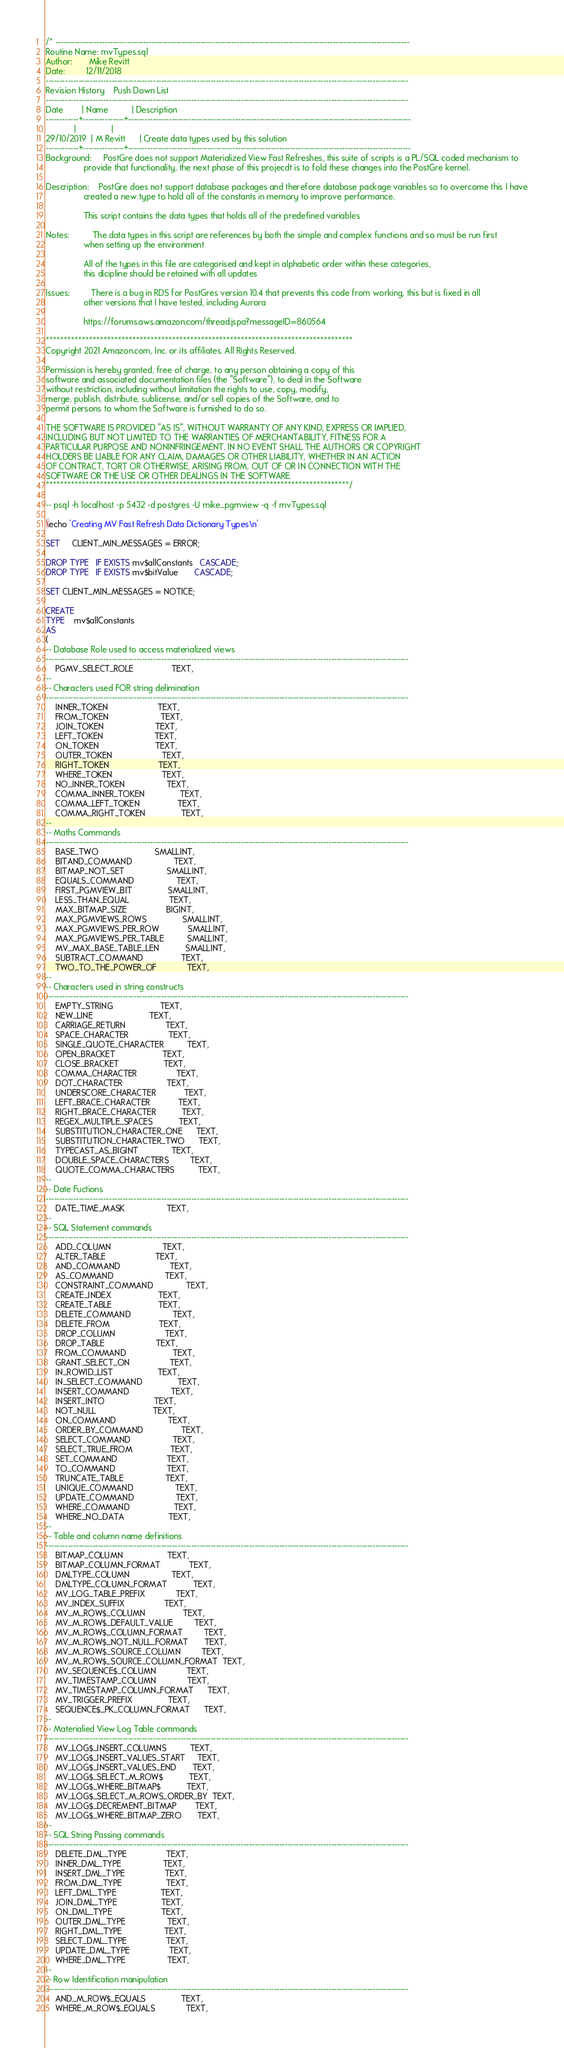<code> <loc_0><loc_0><loc_500><loc_500><_SQL_>/* ---------------------------------------------------------------------------------------------------------------------------------
Routine Name: mvTypes.sql
Author:       Mike Revitt
Date:         12/11/2018
------------------------------------------------------------------------------------------------------------------------------------
Revision History    Push Down List
------------------------------------------------------------------------------------------------------------------------------------
Date        | Name          | Description
------------+---------------+-------------------------------------------------------------------------------------------------------
            |               |
29/10/2019  | M Revitt      | Create data types used by this solution
------------+---------------+-------------------------------------------------------------------------------------------------------
Background:     PostGre does not support Materialized View Fast Refreshes, this suite of scripts is a PL/SQL coded mechanism to
                provide that functionality, the next phase of this projecdt is to fold these changes into the PostGre kernel.

Description:    PostGre does not support database packages and therefore database package variables so to overcome this I have
                created a new type to hold all of the constants in memory to improve performance.

                This script contains the data types that holds all of the predefined variables

Notes:          The data types in this script are references by both the simple and complex functions and so must be run first
                when setting up the environment

                All of the types in this file are categorised and kept in alphabetic order within these categories,
                this dicipline should be retained with all updates

Issues:         There is a bug in RDS for PostGres version 10.4 that prevents this code from working, this but is fixed in all
                other versions that I have tested, including Aurora

                https://forums.aws.amazon.com/thread.jspa?messageID=860564

*************************************************************************************
Copyright 2021 Amazon.com, Inc. or its affiliates. All Rights Reserved.

Permission is hereby granted, free of charge, to any person obtaining a copy of this
software and associated documentation files (the "Software"), to deal in the Software
without restriction, including without limitation the rights to use, copy, modify,
merge, publish, distribute, sublicense, and/or sell copies of the Software, and to
permit persons to whom the Software is furnished to do so.

THE SOFTWARE IS PROVIDED "AS IS", WITHOUT WARRANTY OF ANY KIND, EXPRESS OR IMPLIED,
INCLUDING BUT NOT LIMITED TO THE WARRANTIES OF MERCHANTABILITY, FITNESS FOR A
PARTICULAR PURPOSE AND NONINFRINGEMENT. IN NO EVENT SHALL THE AUTHORS OR COPYRIGHT
HOLDERS BE LIABLE FOR ANY CLAIM, DAMAGES OR OTHER LIABILITY, WHETHER IN AN ACTION
OF CONTRACT, TORT OR OTHERWISE, ARISING FROM, OUT OF OR IN CONNECTION WITH THE
SOFTWARE OR THE USE OR OTHER DEALINGS IN THE SOFTWARE.
************************************************************************************/

-- psql -h localhost -p 5432 -d postgres -U mike_pgmview -q -f mvTypes.sql

\echo 'Creating MV Fast Refresh Data Dictionary Types\n'

SET     CLIENT_MIN_MESSAGES = ERROR;

DROP TYPE   IF EXISTS mv$allConstants   CASCADE;
DROP TYPE   IF EXISTS mv$bitValue       CASCADE;

SET CLIENT_MIN_MESSAGES = NOTICE;

CREATE
TYPE    mv$allConstants
AS
(
-- Database Role used to access materialized views
------------------------------------------------------------------------------------------------------------------------------------
    PGMV_SELECT_ROLE                TEXT,
--
-- Characters used FOR string delimination
------------------------------------------------------------------------------------------------------------------------------------
    INNER_TOKEN                     TEXT,
    FROM_TOKEN                      TEXT,
    JOIN_TOKEN                      TEXT,
    LEFT_TOKEN                      TEXT,
    ON_TOKEN                        TEXT,
    OUTER_TOKEN                     TEXT,
    RIGHT_TOKEN                     TEXT,
    WHERE_TOKEN                     TEXT,
    NO_INNER_TOKEN                  TEXT,
    COMMA_INNER_TOKEN               TEXT,
    COMMA_LEFT_TOKEN                TEXT,
    COMMA_RIGHT_TOKEN               TEXT,
--
-- Maths Commands
------------------------------------------------------------------------------------------------------------------------------------
    BASE_TWO                        SMALLINT,
    BITAND_COMMAND                  TEXT,
    BITMAP_NOT_SET                  SMALLINT,
    EQUALS_COMMAND                  TEXT,
    FIRST_PGMVIEW_BIT               SMALLINT,
    LESS_THAN_EQUAL                 TEXT,
    MAX_BITMAP_SIZE                 BIGINT,
    MAX_PGMVIEWS_ROWS               SMALLINT,
    MAX_PGMVIEWS_PER_ROW            SMALLINT,
    MAX_PGMVIEWS_PER_TABLE          SMALLINT,
    MV_MAX_BASE_TABLE_LEN           SMALLINT,
    SUBTRACT_COMMAND                TEXT,
    TWO_TO_THE_POWER_OF             TEXT,
--
-- Characters used in string constructs
------------------------------------------------------------------------------------------------------------------------------------
    EMPTY_STRING                    TEXT,
    NEW_LINE                        TEXT,
    CARRIAGE_RETURN                 TEXT,
    SPACE_CHARACTER                 TEXT,
    SINGLE_QUOTE_CHARACTER          TEXT,
    OPEN_BRACKET                    TEXT,
    CLOSE_BRACKET                   TEXT,
    COMMA_CHARACTER                 TEXT,
    DOT_CHARACTER                   TEXT,
    UNDERSCORE_CHARACTER            TEXT,
    LEFT_BRACE_CHARACTER            TEXT,
    RIGHT_BRACE_CHARACTER           TEXT,
    REGEX_MULTIPLE_SPACES           TEXT,
    SUBSTITUTION_CHARACTER_ONE      TEXT,
    SUBSTITUTION_CHARACTER_TWO      TEXT,
    TYPECAST_AS_BIGINT              TEXT,
    DOUBLE_SPACE_CHARACTERS         TEXT,
    QUOTE_COMMA_CHARACTERS          TEXT,
--
-- Date Fuctions
------------------------------------------------------------------------------------------------------------------------------------
    DATE_TIME_MASK                  TEXT,
--
-- SQL Statement commands
------------------------------------------------------------------------------------------------------------------------------------
    ADD_COLUMN                      TEXT,
    ALTER_TABLE                     TEXT,
    AND_COMMAND                     TEXT,
    AS_COMMAND                      TEXT,
    CONSTRAINT_COMMAND              TEXT,
    CREATE_INDEX                    TEXT,
    CREATE_TABLE                    TEXT,
    DELETE_COMMAND                  TEXT,
    DELETE_FROM                     TEXT,
    DROP_COLUMN                     TEXT,
    DROP_TABLE                      TEXT,
    FROM_COMMAND                    TEXT,
    GRANT_SELECT_ON                 TEXT,
    IN_ROWID_LIST                   TEXT,
    IN_SELECT_COMMAND               TEXT,
    INSERT_COMMAND                  TEXT,
    INSERT_INTO                     TEXT,
    NOT_NULL                        TEXT,
    ON_COMMAND                      TEXT,
    ORDER_BY_COMMAND                TEXT,
    SELECT_COMMAND                  TEXT,
    SELECT_TRUE_FROM                TEXT,
    SET_COMMAND                     TEXT,
    TO_COMMAND                      TEXT,
    TRUNCATE_TABLE                  TEXT,
    UNIQUE_COMMAND                  TEXT,
    UPDATE_COMMAND                  TEXT,
    WHERE_COMMAND                   TEXT,
    WHERE_NO_DATA                   TEXT,
--
-- Table and column name definitions
------------------------------------------------------------------------------------------------------------------------------------
    BITMAP_COLUMN                   TEXT,
    BITMAP_COLUMN_FORMAT            TEXT,
    DMLTYPE_COLUMN                  TEXT,
    DMLTYPE_COLUMN_FORMAT           TEXT,
    MV_LOG_TABLE_PREFIX             TEXT,
    MV_INDEX_SUFFIX                 TEXT,
    MV_M_ROW$_COLUMN                TEXT,
    MV_M_ROW$_DEFAULT_VALUE         TEXT,
    MV_M_ROW$_COLUMN_FORMAT         TEXT,
    MV_M_ROW$_NOT_NULL_FORMAT       TEXT,
    MV_M_ROW$_SOURCE_COLUMN         TEXT,
    MV_M_ROW$_SOURCE_COLUMN_FORMAT  TEXT,
    MV_SEQUENCE$_COLUMN             TEXT,
    MV_TIMESTAMP_COLUMN             TEXT,
    MV_TIMESTAMP_COLUMN_FORMAT      TEXT,
    MV_TRIGGER_PREFIX               TEXT,
    SEQUENCE$_PK_COLUMN_FORMAT      TEXT,
--
-- Materialied View Log Table commands
------------------------------------------------------------------------------------------------------------------------------------
    MV_LOG$_INSERT_COLUMNS          TEXT,
    MV_LOG$_INSERT_VALUES_START     TEXT,
    MV_LOG$_INSERT_VALUES_END       TEXT,
    MV_LOG$_SELECT_M_ROW$           TEXT,
    MV_LOG$_WHERE_BITMAP$           TEXT,
    MV_LOG$_SELECT_M_ROWS_ORDER_BY  TEXT,
    MV_LOG$_DECREMENT_BITMAP        TEXT,
    MV_LOG$_WHERE_BITMAP_ZERO       TEXT,
--
-- SQL String Passing commands
------------------------------------------------------------------------------------------------------------------------------------
    DELETE_DML_TYPE                 TEXT,
    INNER_DML_TYPE                  TEXT,
    INSERT_DML_TYPE                 TEXT,
    FROM_DML_TYPE                   TEXT,
    LEFT_DML_TYPE                   TEXT,
    JOIN_DML_TYPE                   TEXT,
    ON_DML_TYPE                     TEXT,
    OUTER_DML_TYPE                  TEXT,
    RIGHT_DML_TYPE                  TEXT,
    SELECT_DML_TYPE                 TEXT,
    UPDATE_DML_TYPE                 TEXT,
    WHERE_DML_TYPE                  TEXT,
--
-- Row Identification manipulation
------------------------------------------------------------------------------------------------------------------------------------
    AND_M_ROW$_EQUALS               TEXT,
    WHERE_M_ROW$_EQUALS             TEXT,</code> 